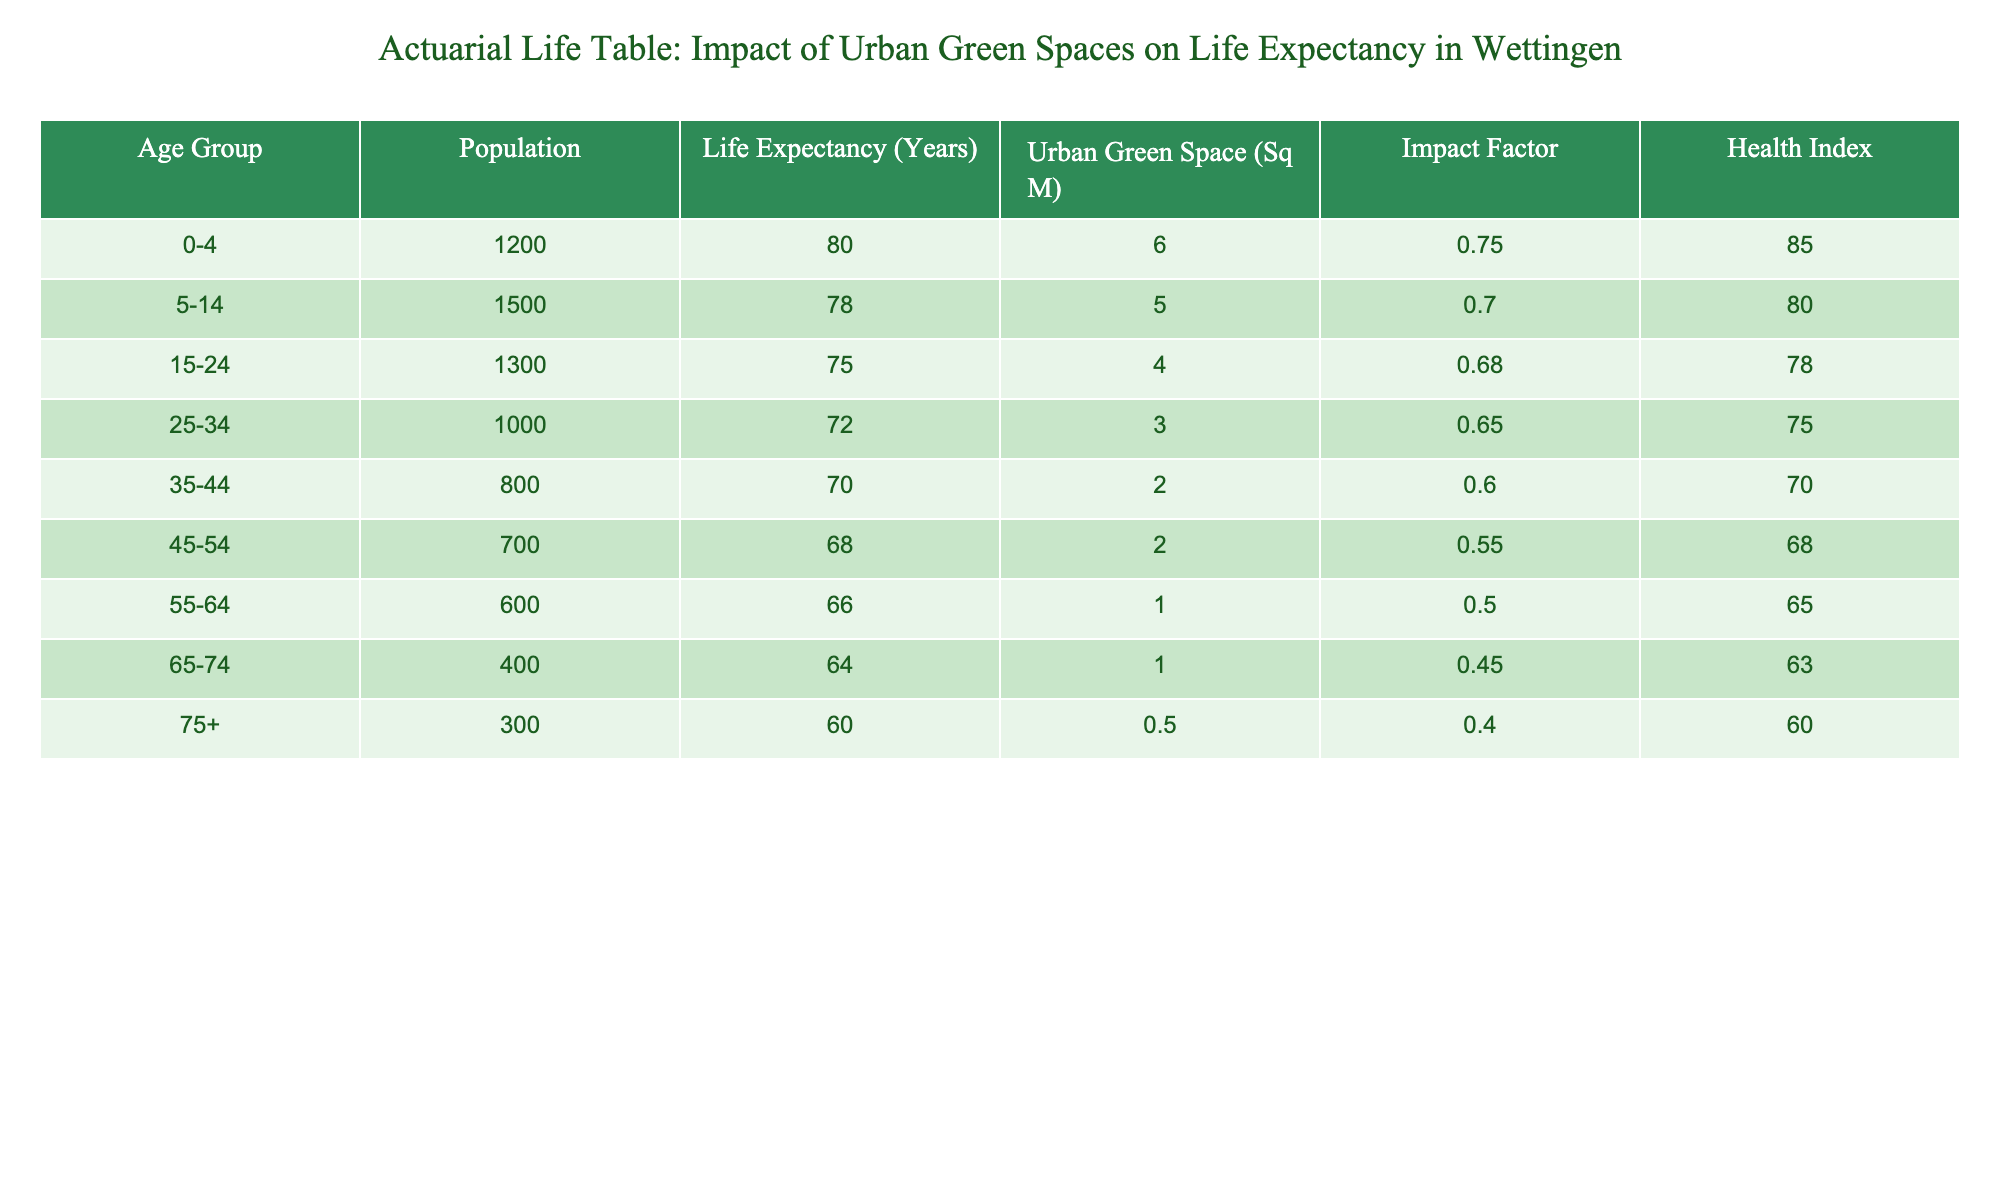What is the life expectancy for the 0-4 age group? According to the table, the life expectancy for the 0-4 age group is listed directly under the "Life Expectancy (Years)" column, which shows the value of 80 years.
Answer: 80 years Which age group has the highest health index? The "Health Index" column indicates the health scores for each age group. By reviewing the values, the age group 0-4 has the highest health index of 85.
Answer: 0-4 What is the average life expectancy across all age groups? To find the average, sum all life expectancy values: 80 + 78 + 75 + 72 + 70 + 68 + 66 + 64 + 60 = 633. There are 9 age groups, so the average life expectancy is 633/9 ≈ 70.33 years.
Answer: 70.33 years Is the impact factor higher for the 55-64 age group than for the 35-44 age group? By comparing the "Impact Factor" column values, the 55-64 age group has an impact factor of 0.50, while the 35-44 age group has an impact factor of 0.60. Since 0.50 is not higher than 0.60, the statement is false.
Answer: No What is the total urban green space for the age group 15-24 compared to the 75+ age group? The urban green space for the age group 15-24 is listed as 4 sq m and for the 75+ age group, it is 0.5 sq m. The total for the 15-24 age group is greater than that for the 75+ age group, making it 4 sq m > 0.5 sq m.
Answer: Yes If we were to increase the urban green space for the 35-44 age group by 50%, what would the new value be? The current urban green space for the 35-44 age group is 2 sq m. Increasing this by 50% means adding 1 sq m (0.50 * 2 = 1). Therefore, the new value would be 2 + 1 = 3 sq m.
Answer: 3 sq m Which age group has the least urban green space per person? To find the least urban green space per person, divide the urban green space by the population for each age group. The 75+ age group has 0.5 sq m for 300 people, resulting in 0.5/300 = 0.00167 sq m per person, which is the least compared to other age groups.
Answer: 75+ Is there any age group with a health index below 65? By reviewing the "Health Index" values, the age groups 55-64 (65) and 75+ (60) show that 75+ has an index below 65. Therefore, there is at least one age group with a health index below 65.
Answer: Yes 